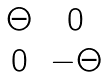Convert formula to latex. <formula><loc_0><loc_0><loc_500><loc_500>\begin{matrix} \Theta & 0 \\ 0 & - \Theta \end{matrix}</formula> 